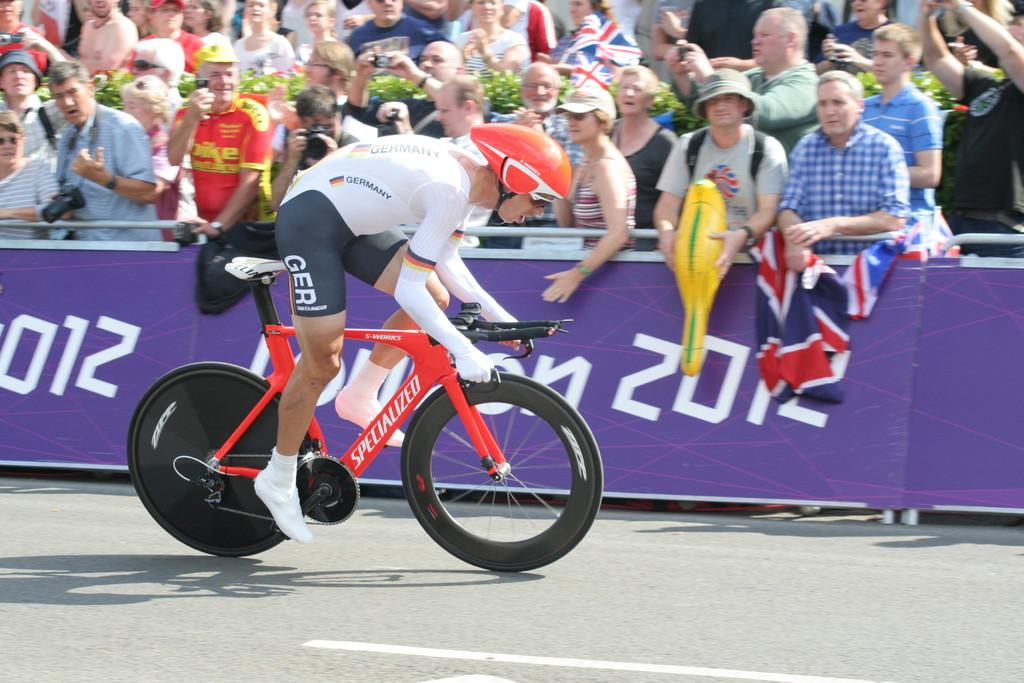What are the people in the image doing? There is a group of people standing, a person riding a bicycle, and a person holding a flag. What can be seen in the background of the image? The image shows a road. What is the person wearing a helmet doing? The person wearing a helmet is likely riding the bicycle. What might the person holding a camera be doing? The person holding a camera might be taking pictures or recording the scene. Where is the desk located in the image? There is no desk present in the image. Can you see any donkeys in the image? There are no donkeys visible in the image. 